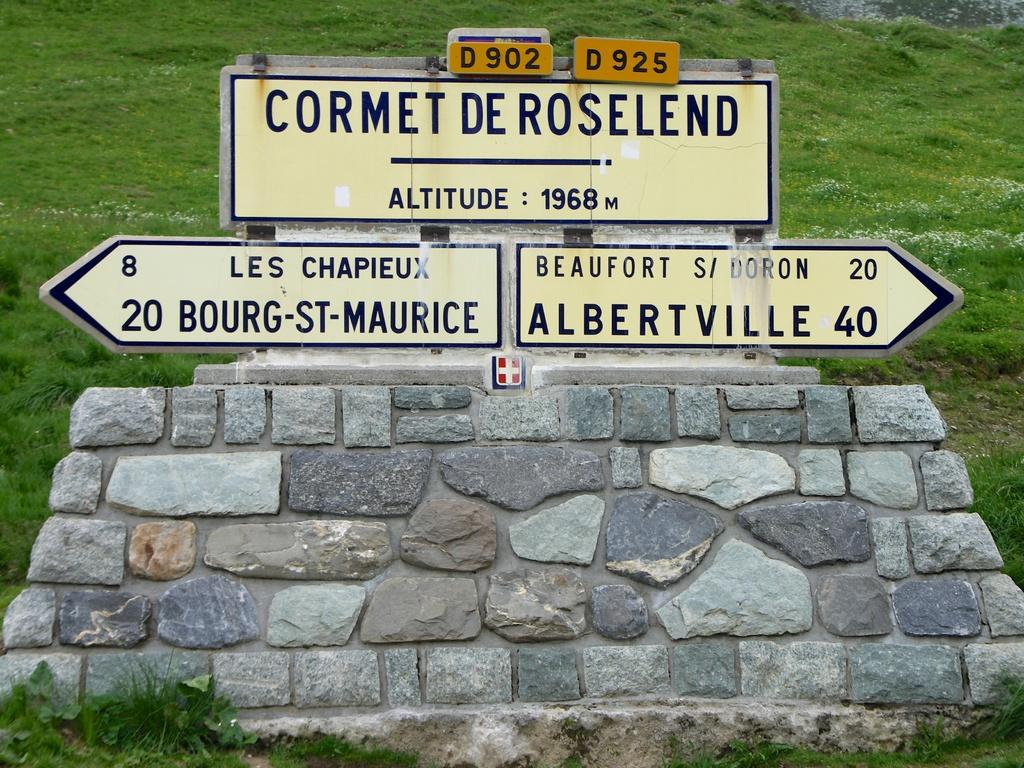Which direction goes to albertville?
Your answer should be very brief. Right. How many miles to albertville?
Give a very brief answer. 40. 